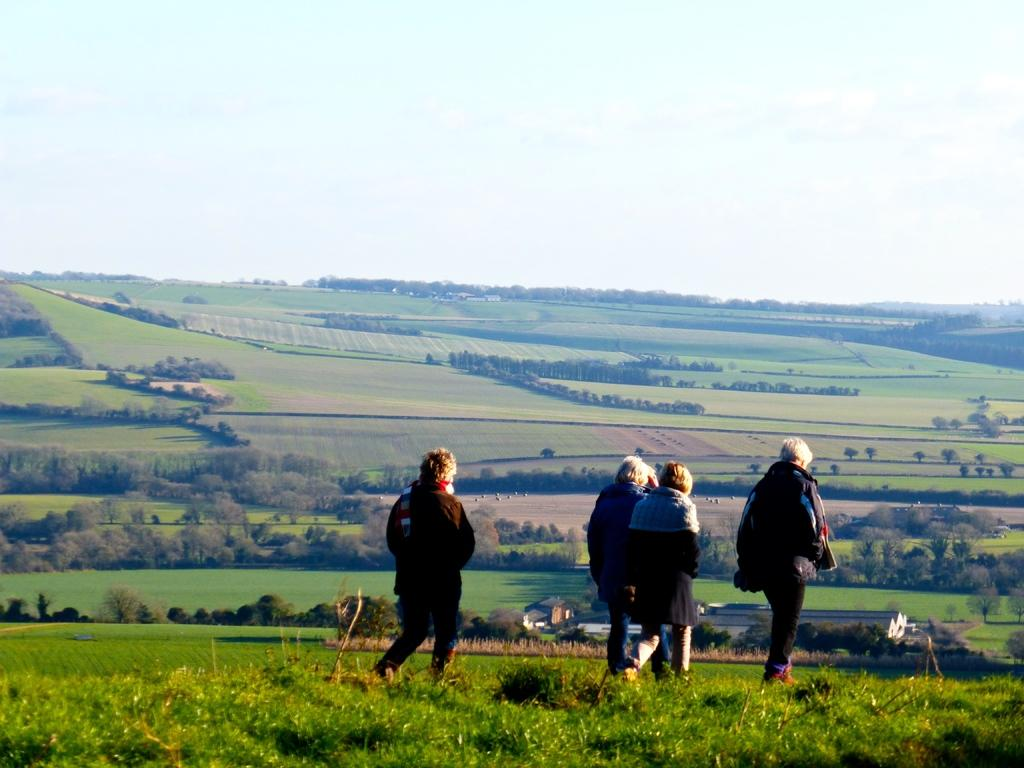What are the people in the image doing? The people in the image are walking. What type of clothing are the people wearing? The people are wearing coats. What is the ground made of in the image? There is grass on the ground in the image. What type of vegetation can be seen in the image? There are trees visible in the image. What is the condition of the sky in the image? The sky is cloudy in the image. Can you tell me how many balloons are tied to the trees in the image? There are no balloons present in the image; it only features people walking, grass, trees, and a cloudy sky. What type of trouble are the people facing in the image? There is no indication of trouble or any problematic situation in the image; it simply shows people walking while wearing coats. 